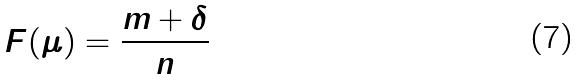Convert formula to latex. <formula><loc_0><loc_0><loc_500><loc_500>F ( \mu ) = \frac { m + \delta } { n }</formula> 